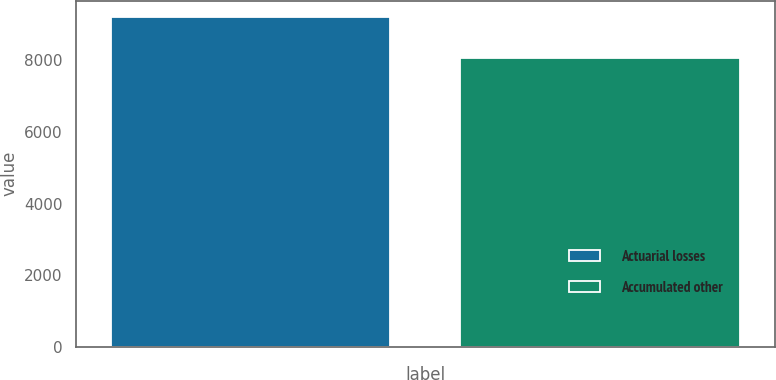Convert chart to OTSL. <chart><loc_0><loc_0><loc_500><loc_500><bar_chart><fcel>Actuarial losses<fcel>Accumulated other<nl><fcel>9208<fcel>8061<nl></chart> 